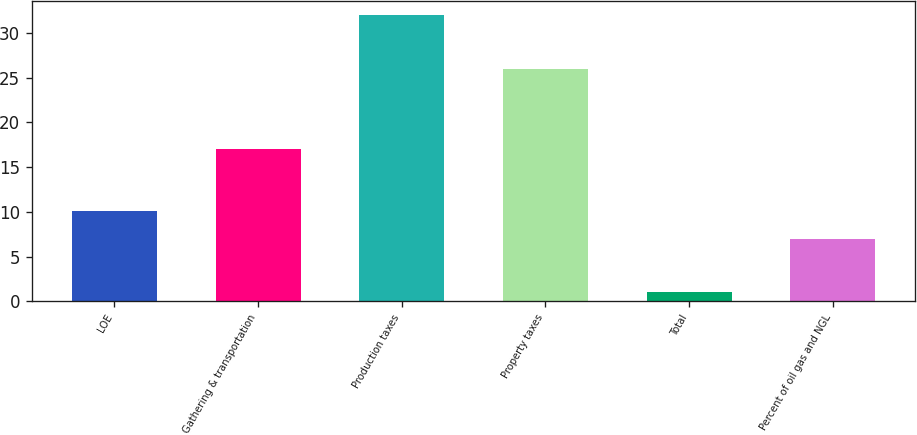Convert chart to OTSL. <chart><loc_0><loc_0><loc_500><loc_500><bar_chart><fcel>LOE<fcel>Gathering & transportation<fcel>Production taxes<fcel>Property taxes<fcel>Total<fcel>Percent of oil gas and NGL<nl><fcel>10.1<fcel>17<fcel>32<fcel>26<fcel>1<fcel>7<nl></chart> 